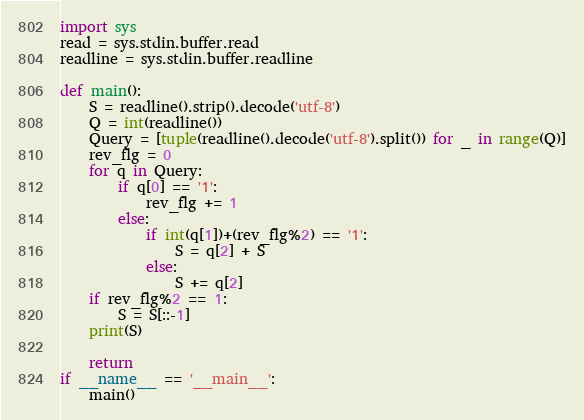<code> <loc_0><loc_0><loc_500><loc_500><_Python_>import sys
read = sys.stdin.buffer.read
readline = sys.stdin.buffer.readline

def main():
    S = readline().strip().decode('utf-8')
    Q = int(readline())
    Query = [tuple(readline().decode('utf-8').split()) for _ in range(Q)]
    rev_flg = 0
    for q in Query:
        if q[0] == '1':
            rev_flg += 1
        else:
            if int(q[1])+(rev_flg%2) == '1':
                S = q[2] + S
            else:
                S += q[2]
    if rev_flg%2 == 1:
        S = S[::-1]
    print(S)

    return
if __name__ == '__main__':
    main()

</code> 